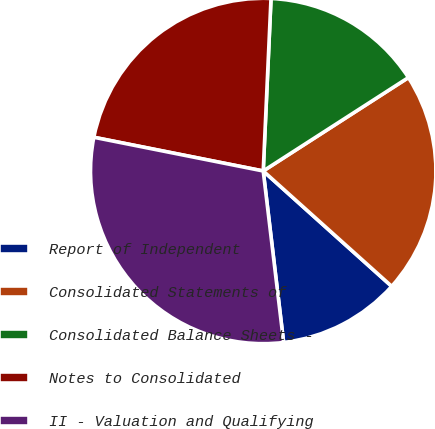Convert chart. <chart><loc_0><loc_0><loc_500><loc_500><pie_chart><fcel>Report of Independent<fcel>Consolidated Statements of<fcel>Consolidated Balance Sheets -<fcel>Notes to Consolidated<fcel>II - Valuation and Qualifying<nl><fcel>11.47%<fcel>20.74%<fcel>15.18%<fcel>22.59%<fcel>30.01%<nl></chart> 